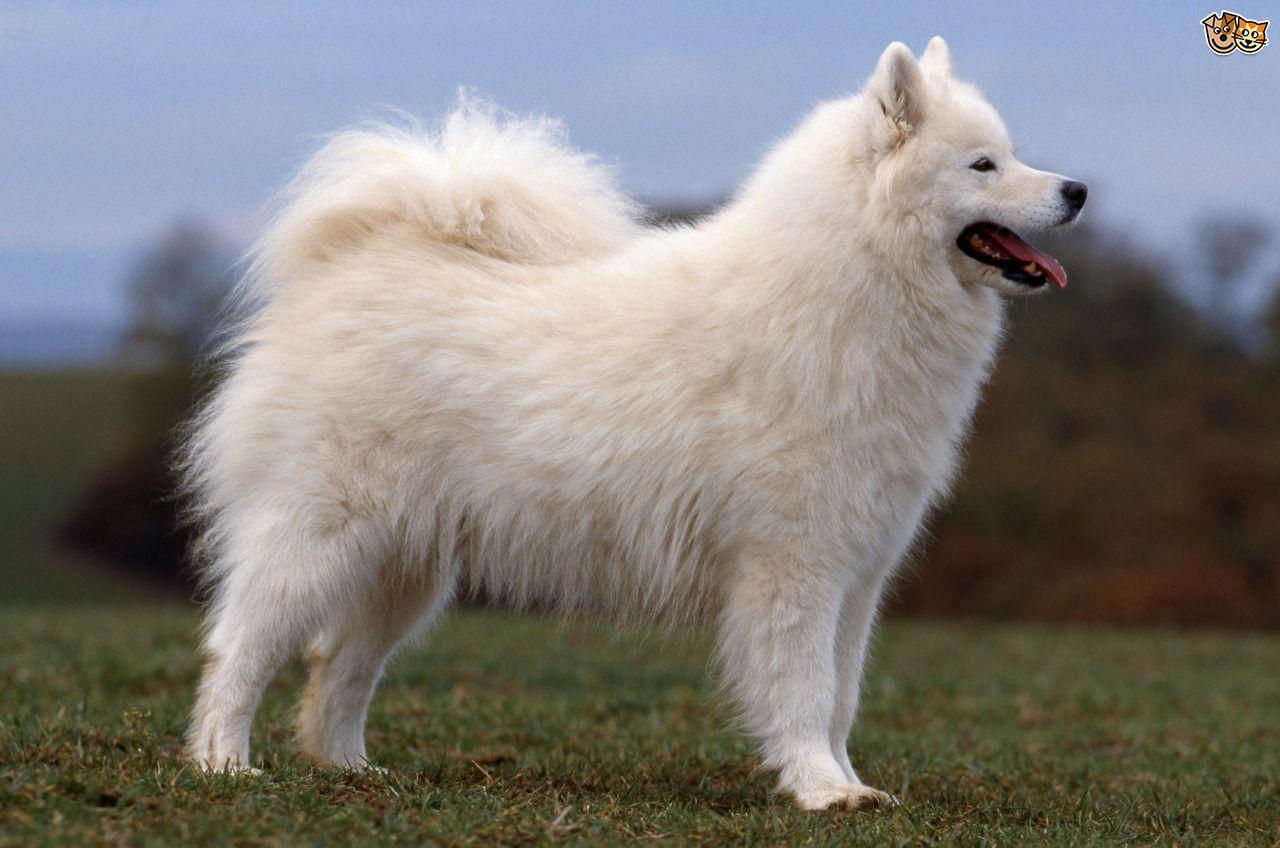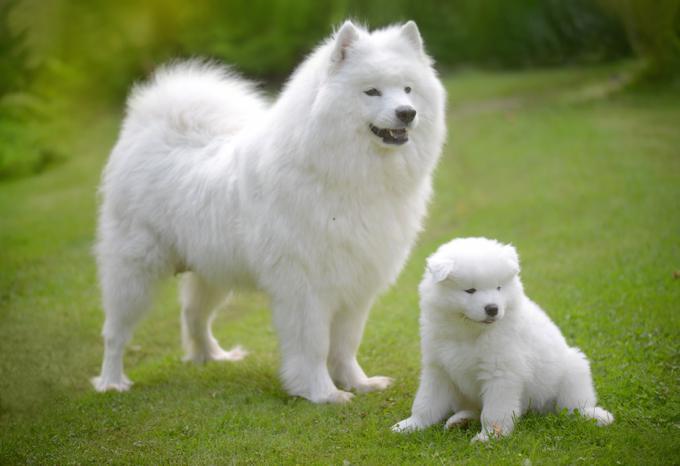The first image is the image on the left, the second image is the image on the right. Examine the images to the left and right. Is the description "An adult dog is lying down next to a puppy." accurate? Answer yes or no. No. 